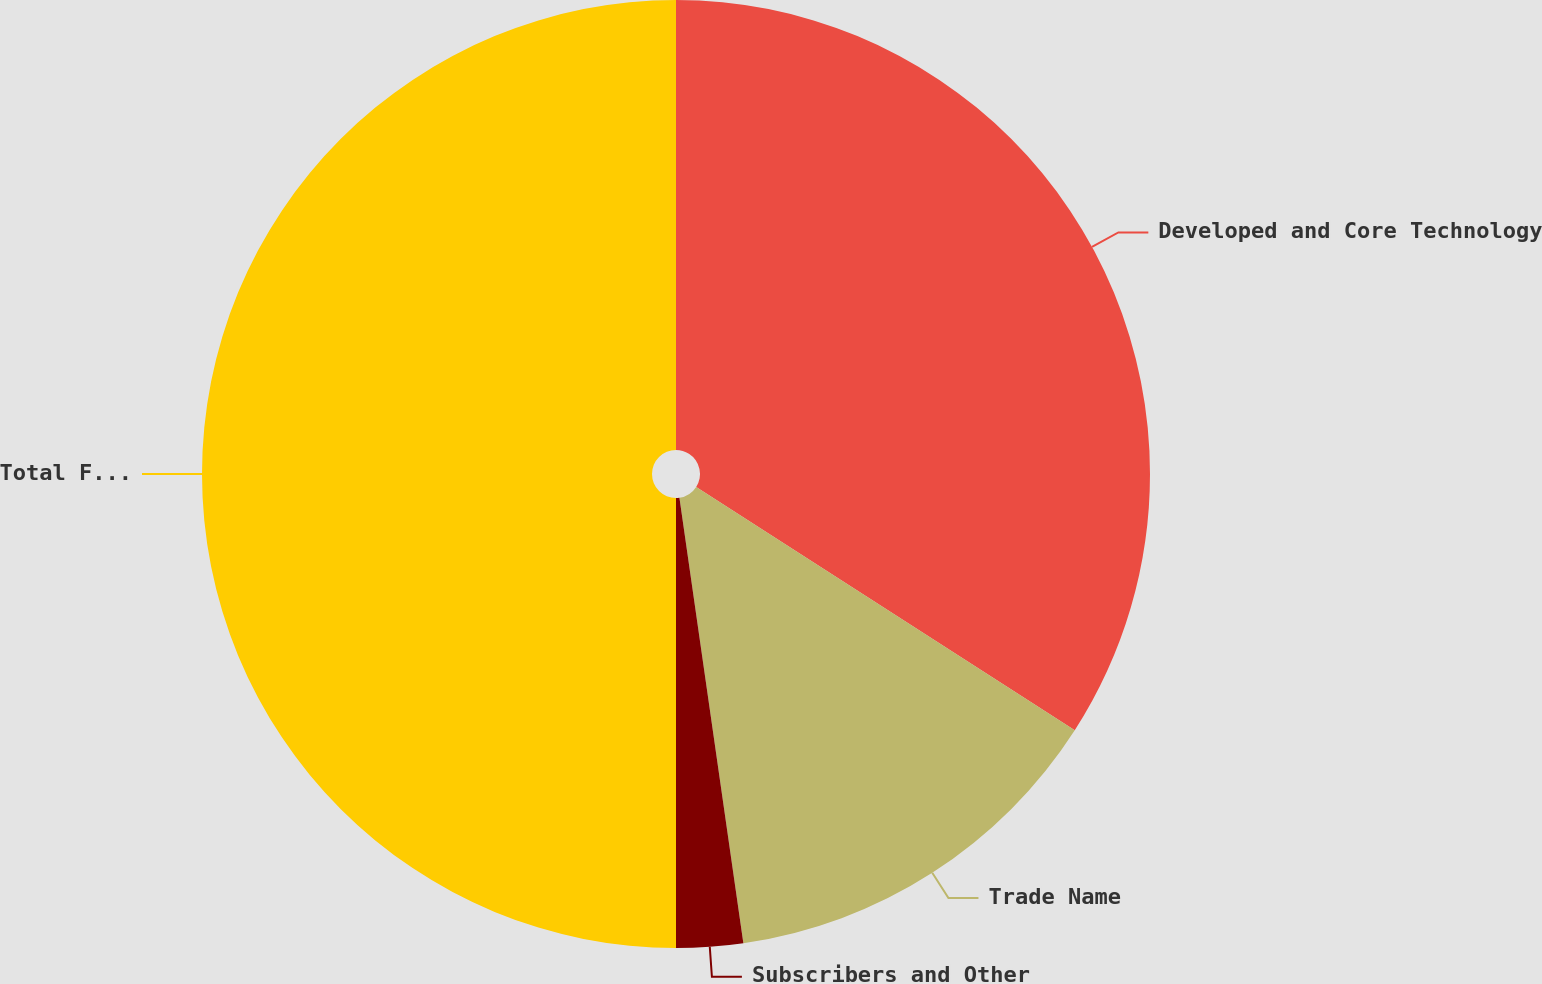<chart> <loc_0><loc_0><loc_500><loc_500><pie_chart><fcel>Developed and Core Technology<fcel>Trade Name<fcel>Subscribers and Other<fcel>Total Finite-Lived Intangibles<nl><fcel>34.09%<fcel>13.64%<fcel>2.27%<fcel>50.0%<nl></chart> 